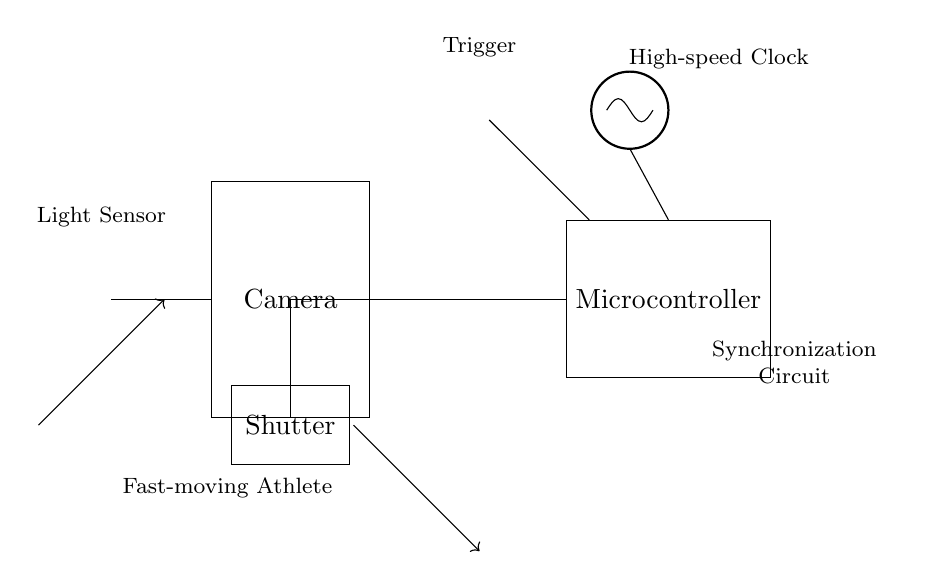What is the main function of the light sensor in the circuit? The light sensor detects the presence of light reflected from the athlete, which triggers the camera shutter mechanism to capture an image.
Answer: Detection What component is responsible for the timing of the shutter release? The high-speed clock generates precise timing signals that dictate when the shutter will open and close, enabling synchronization with fast-moving objects.
Answer: High-speed clock What initiates the shutter mechanism to capture an image? The trigger button, when pressed, sends a signal to the microcontroller, which in turn controls the shutter mechanism to capture the image.
Answer: Trigger button How many main components are involved in this synchronization circuit? The main components are the camera, shutter, microcontroller, high-speed clock, light sensor, and trigger button, totaling six.
Answer: Six What is the relationship between the shutter and microcontroller in the circuit? The microcontroller sends control signals to the shutter based on input from the light sensor and trigger, effectively managing the shutter operation for synchronization.
Answer: Control signals What type of circuit is this described as? It is a synchronous circuit because it relies on a clock signal to synchronize the operation of the camera shutter with the motion of the athlete.
Answer: Synchronous 